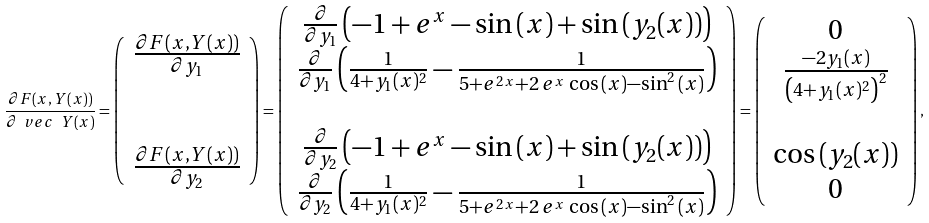<formula> <loc_0><loc_0><loc_500><loc_500>\frac { \partial F ( x , Y ( x ) ) } { \partial \ v e c \ Y ( x ) } = \left ( \begin{array} { c } \frac { \partial F ( x , Y ( x ) ) } { \partial y _ { 1 } } \\ \\ \\ \frac { \partial F ( x , Y ( x ) ) } { \partial y _ { 2 } } \end{array} \right ) = \left ( \begin{array} { c } \frac { \partial } { \partial y _ { 1 } } \left ( - 1 + e ^ { x } - \sin { ( x ) } + \sin { ( y _ { 2 } ( x ) ) } \right ) \\ \frac { \partial } { \partial y _ { 1 } } \left ( \frac { 1 } { 4 + y _ { 1 } ( x ) ^ { 2 } } - \frac { 1 } { 5 + e ^ { 2 \, x } + 2 \, e ^ { x } \, \cos { ( x ) } - \sin ^ { 2 } { ( x ) } } \right ) \\ \\ \frac { \partial } { \partial y _ { 2 } } \left ( - 1 + e ^ { x } - \sin { ( x ) } + \sin { ( y _ { 2 } ( x ) ) } \right ) \\ \frac { \partial } { \partial y _ { 2 } } \left ( \frac { 1 } { 4 + y _ { 1 } ( x ) ^ { 2 } } - \frac { 1 } { 5 + e ^ { 2 \, x } + 2 \, e ^ { x } \, \cos { ( x ) } - \sin ^ { 2 } { ( x ) } } \right ) \\ \end{array} \right ) = \left ( \begin{array} { c } 0 \\ \frac { - 2 y _ { 1 } ( x ) } { \left ( 4 + y _ { 1 } ( x ) ^ { 2 } \right ) ^ { 2 } } \\ \\ \cos { ( y _ { 2 } ( x ) ) } \\ 0 \\ \end{array} \right ) ,</formula> 